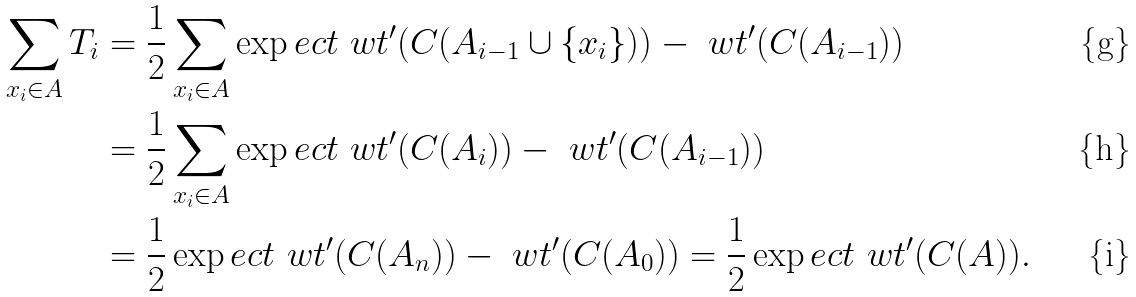<formula> <loc_0><loc_0><loc_500><loc_500>\sum _ { x _ { i } \in A } T _ { i } & = \frac { 1 } { 2 } \sum _ { x _ { i } \in A } \exp e c t { \ w t ^ { \prime } ( C ( A _ { i - 1 } \cup \{ x _ { i } \} ) ) - \ w t ^ { \prime } ( C ( A _ { i - 1 } ) ) } \\ & = \frac { 1 } { 2 } \sum _ { x _ { i } \in A } \exp e c t { \ w t ^ { \prime } ( C ( A _ { i } ) ) - \ w t ^ { \prime } ( C ( A _ { i - 1 } ) ) } \\ & = \frac { 1 } { 2 } \exp e c t { \ w t ^ { \prime } ( C ( A _ { n } ) ) - \ w t ^ { \prime } ( C ( A _ { 0 } ) ) } = \frac { 1 } { 2 } \exp e c t { \ w t ^ { \prime } ( C ( A ) ) } .</formula> 